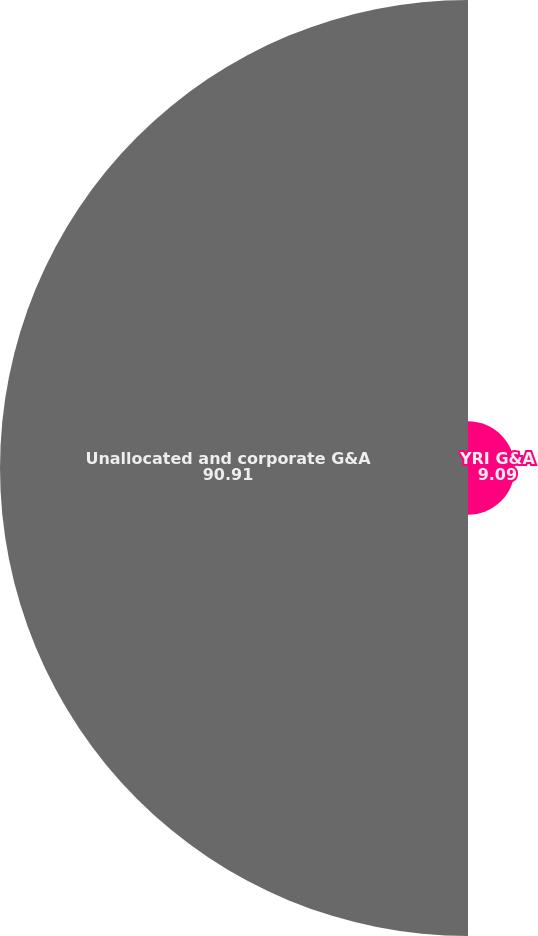<chart> <loc_0><loc_0><loc_500><loc_500><pie_chart><fcel>YRI G&A<fcel>Unallocated and corporate G&A<nl><fcel>9.09%<fcel>90.91%<nl></chart> 